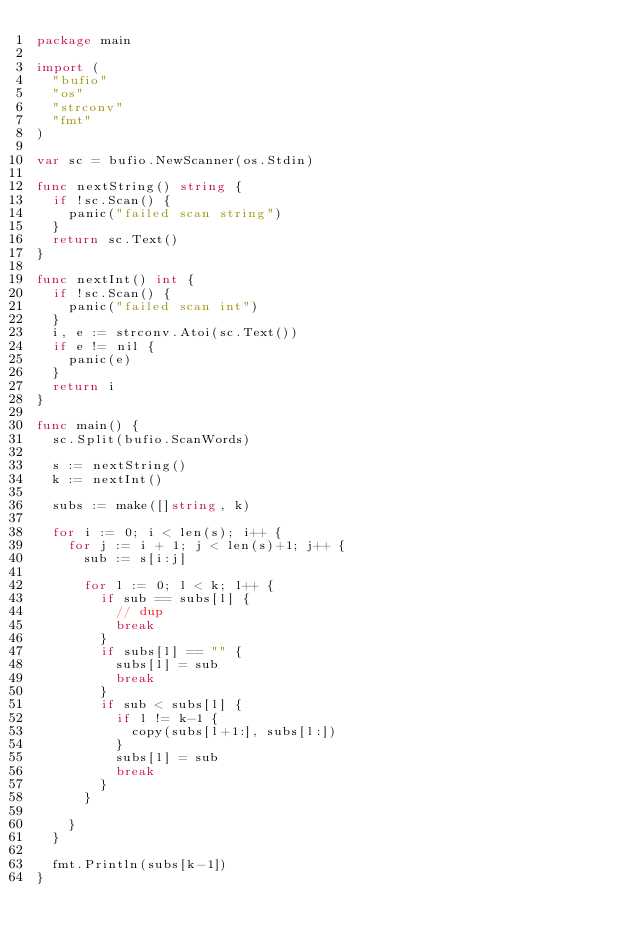Convert code to text. <code><loc_0><loc_0><loc_500><loc_500><_Go_>package main

import (
	"bufio"
	"os"
	"strconv"
	"fmt"
)

var sc = bufio.NewScanner(os.Stdin)

func nextString() string {
	if !sc.Scan() {
		panic("failed scan string")
	}
	return sc.Text()
}

func nextInt() int {
	if !sc.Scan() {
		panic("failed scan int")
	}
	i, e := strconv.Atoi(sc.Text())
	if e != nil {
		panic(e)
	}
	return i
}

func main() {
	sc.Split(bufio.ScanWords)

	s := nextString()
	k := nextInt()

	subs := make([]string, k)

	for i := 0; i < len(s); i++ {
		for j := i + 1; j < len(s)+1; j++ {
			sub := s[i:j]

			for l := 0; l < k; l++ {
				if sub == subs[l] {
					// dup
					break
				}
				if subs[l] == "" {
					subs[l] = sub
					break
				}
				if sub < subs[l] {
					if l != k-1 {
						copy(subs[l+1:], subs[l:])
					}
					subs[l] = sub
					break
				}
			}

		}
	}

	fmt.Println(subs[k-1])
}
</code> 